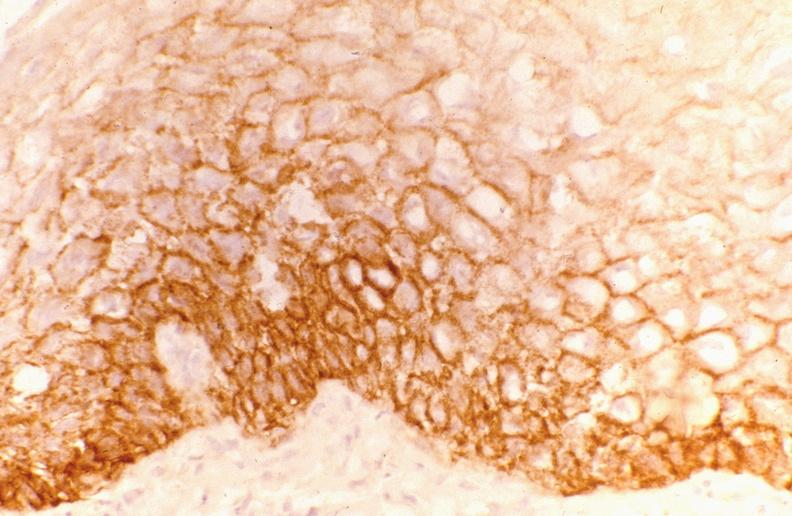s stillborn macerated present?
Answer the question using a single word or phrase. No 